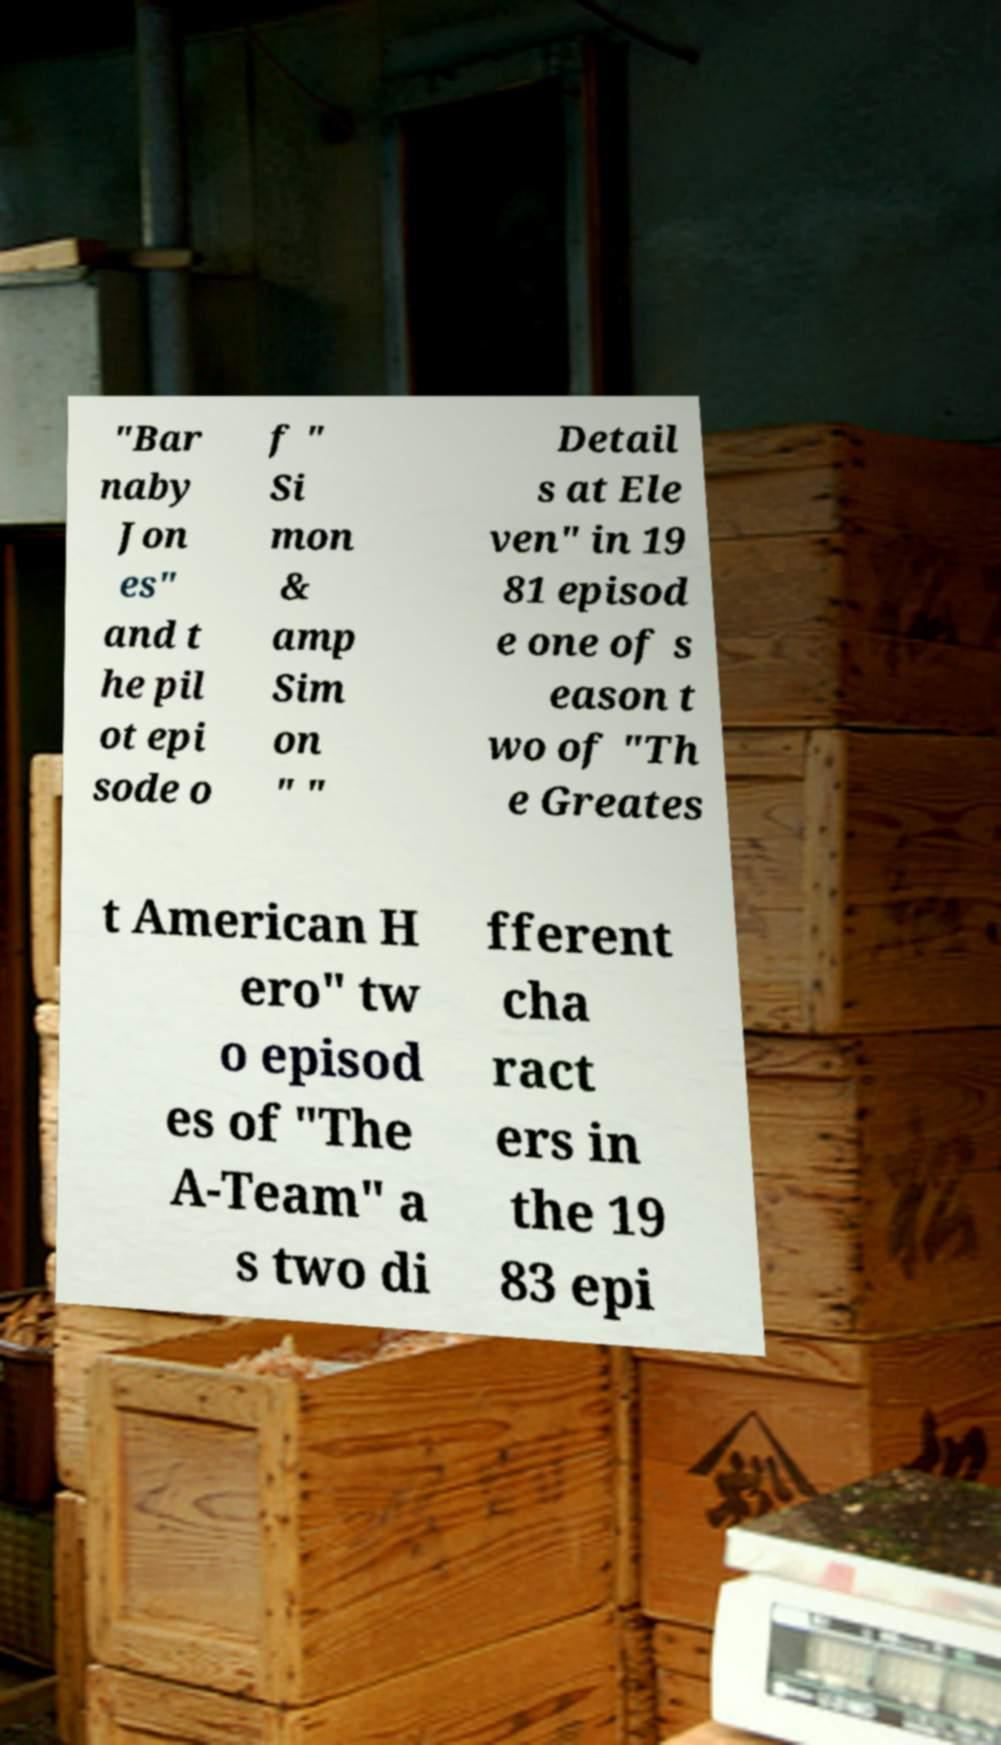I need the written content from this picture converted into text. Can you do that? "Bar naby Jon es" and t he pil ot epi sode o f " Si mon & amp Sim on " " Detail s at Ele ven" in 19 81 episod e one of s eason t wo of "Th e Greates t American H ero" tw o episod es of "The A-Team" a s two di fferent cha ract ers in the 19 83 epi 